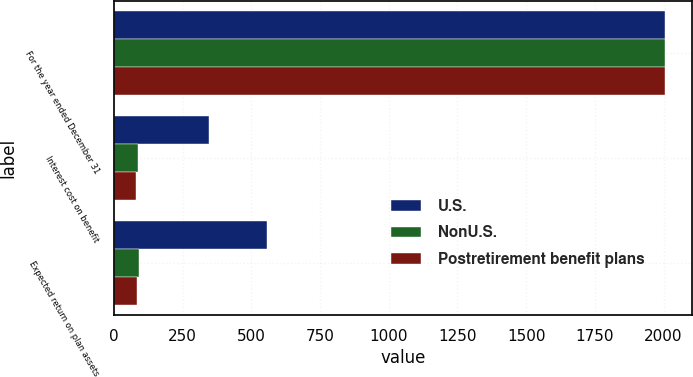Convert chart to OTSL. <chart><loc_0><loc_0><loc_500><loc_500><stacked_bar_chart><ecel><fcel>For the year ended December 31<fcel>Interest cost on benefit<fcel>Expected return on plan assets<nl><fcel>U.S.<fcel>2004<fcel>348<fcel>556<nl><fcel>NonU.S.<fcel>2004<fcel>87<fcel>90<nl><fcel>Postretirement benefit plans<fcel>2004<fcel>81<fcel>86<nl></chart> 